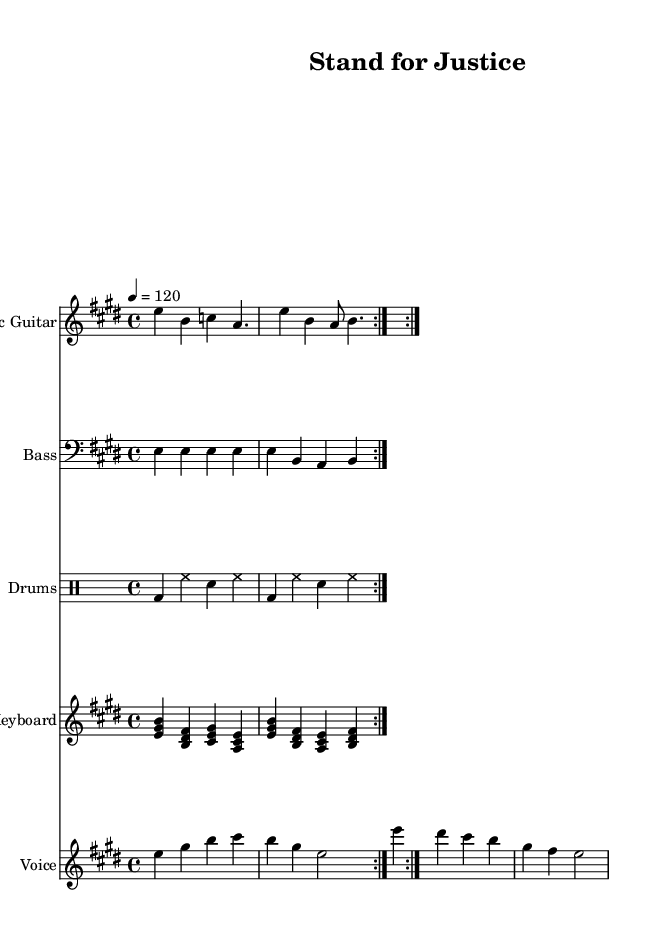What is the key signature of this music? The key signature is E major, which contains four sharps: F#, C#, G#, and D#. It can be identified at the beginning of the score.
Answer: E major What is the time signature of this piece? The time signature is located at the beginning of the music and is indicated as 4/4, meaning there are four beats in each measure and a quarter note gets one beat.
Answer: 4/4 What is the tempo marking given in the music? The tempo marking shown at the top of the score indicates a speed of 120 beats per minute, specified with "4 = 120". This means quarter note is equal to 120 beats per minute.
Answer: 120 How many times is the main melody repeated in the score? The main melody is shown to be repeated two times, as indicated by the "repeat volta 2" instruction before the melody segment, suggesting a repeated section.
Answer: 2 What are the primary instruments featured in this arrangement? The instruments in the score include Electric Guitar, Bass, Drums, and Keyboard, which are all notated in separate staves and can be identified by their names.
Answer: Electric Guitar, Bass, Drums, Keyboard Based on the lyrics, what is the main theme of the song? The lyrics emphasize standing for justice and fighting for freedom, which can be understood by directly analyzing the words provided in the lyrics section of the score.
Answer: Justice and Freedom 